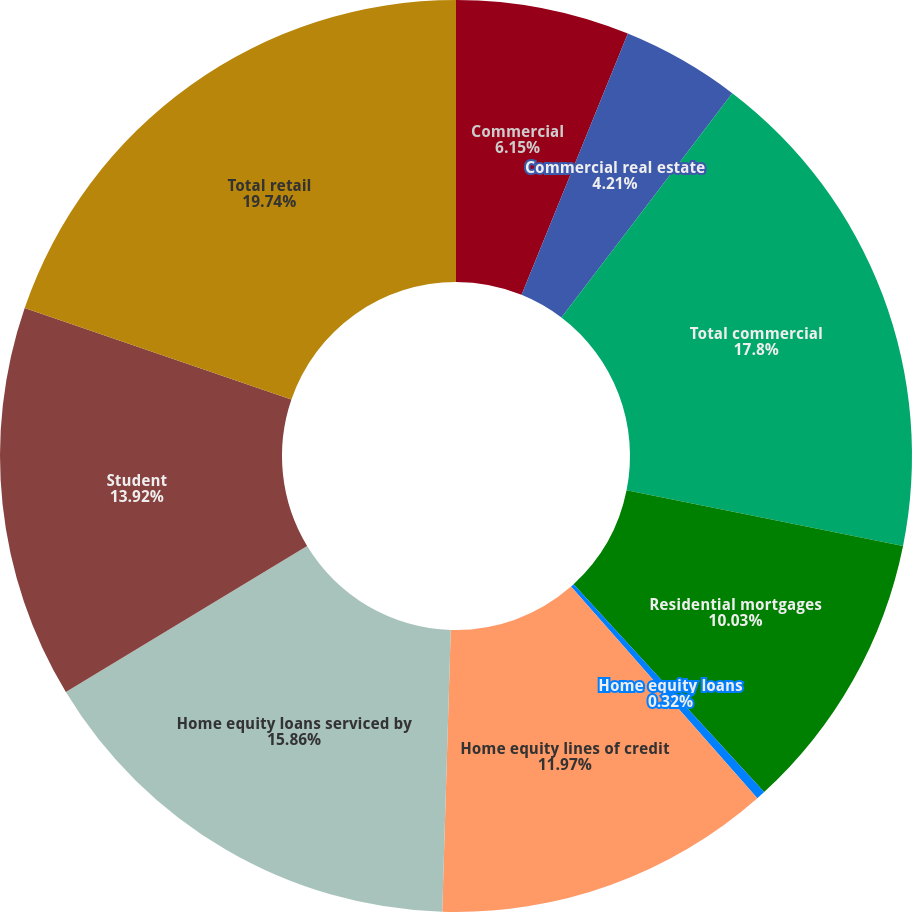Convert chart. <chart><loc_0><loc_0><loc_500><loc_500><pie_chart><fcel>Commercial<fcel>Commercial real estate<fcel>Total commercial<fcel>Residential mortgages<fcel>Home equity loans<fcel>Home equity lines of credit<fcel>Home equity loans serviced by<fcel>Student<fcel>Total retail<nl><fcel>6.15%<fcel>4.21%<fcel>17.8%<fcel>10.03%<fcel>0.32%<fcel>11.97%<fcel>15.86%<fcel>13.92%<fcel>19.74%<nl></chart> 